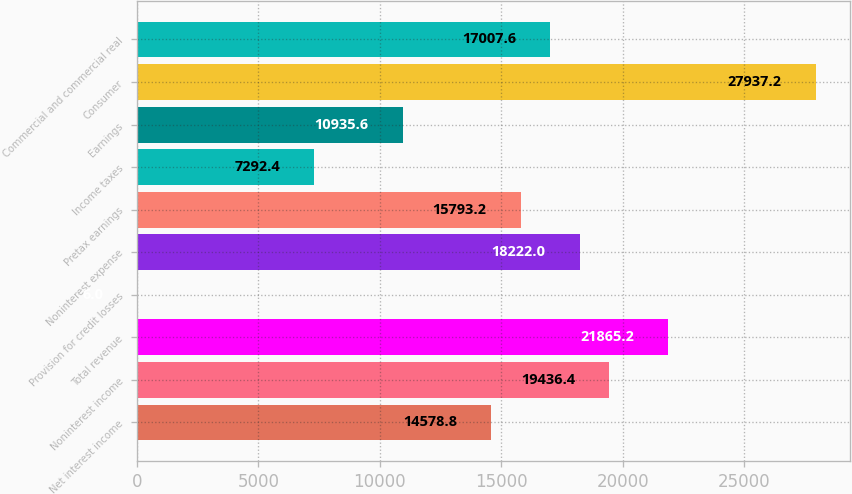Convert chart to OTSL. <chart><loc_0><loc_0><loc_500><loc_500><bar_chart><fcel>Net interest income<fcel>Noninterest income<fcel>Total revenue<fcel>Provision for credit losses<fcel>Noninterest expense<fcel>Pretax earnings<fcel>Income taxes<fcel>Earnings<fcel>Consumer<fcel>Commercial and commercial real<nl><fcel>14578.8<fcel>19436.4<fcel>21865.2<fcel>6<fcel>18222<fcel>15793.2<fcel>7292.4<fcel>10935.6<fcel>27937.2<fcel>17007.6<nl></chart> 